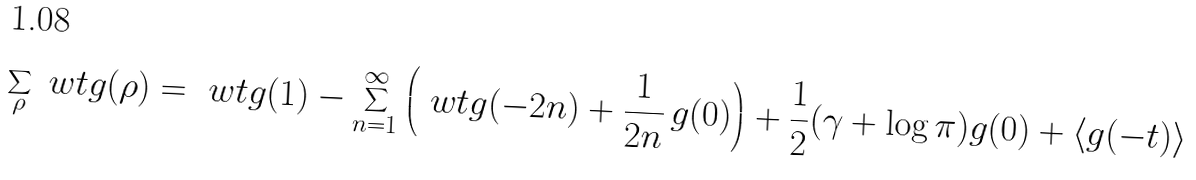<formula> <loc_0><loc_0><loc_500><loc_500>\sum _ { \rho } \ w t g ( \rho ) = \ w t g ( 1 ) - \sum _ { n = 1 } ^ { \infty } \left ( \ w t g ( - 2 n ) + \frac { 1 } { 2 n } \, g ( 0 ) \right ) + \frac { 1 } { 2 } ( \gamma + \log \pi ) g ( 0 ) + \langle g ( - t ) \rangle</formula> 